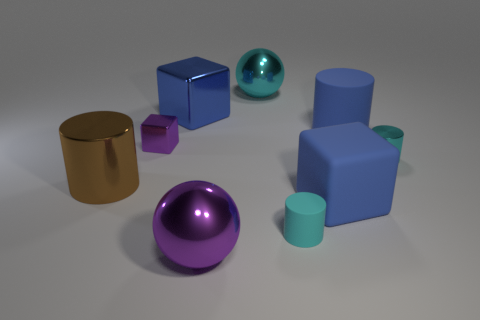Are there any big shiny objects to the right of the tiny cyan metallic thing?
Give a very brief answer. No. There is another sphere that is the same size as the purple shiny sphere; what color is it?
Your answer should be compact. Cyan. What number of objects are either cyan things in front of the small purple metal cube or large yellow shiny blocks?
Keep it short and to the point. 2. There is a cylinder that is both to the left of the blue cylinder and to the right of the large brown shiny object; what size is it?
Offer a very short reply. Small. There is another cylinder that is the same color as the small matte cylinder; what is its size?
Your answer should be compact. Small. What number of other objects are there of the same size as the purple sphere?
Provide a succinct answer. 5. There is a block in front of the tiny cylinder that is on the right side of the big blue block that is to the right of the large cyan metallic thing; what color is it?
Provide a short and direct response. Blue. What is the shape of the metal thing that is on the left side of the small shiny cylinder and right of the purple ball?
Your answer should be very brief. Sphere. How many other objects are there of the same shape as the brown object?
Make the answer very short. 3. There is a purple object behind the cyan cylinder that is in front of the big blue block in front of the brown shiny cylinder; what is its shape?
Give a very brief answer. Cube. 